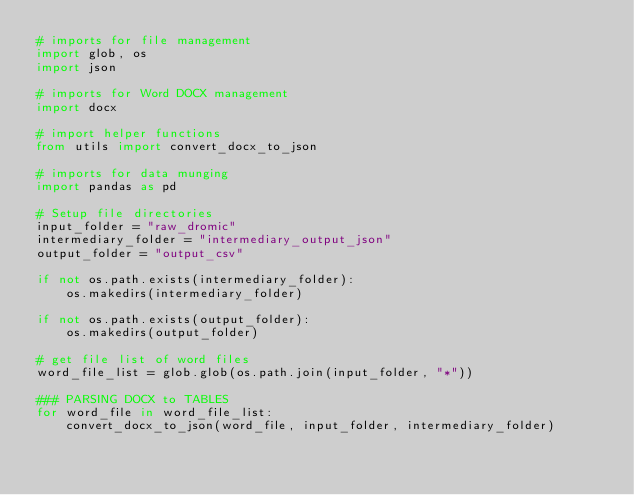Convert code to text. <code><loc_0><loc_0><loc_500><loc_500><_Python_># imports for file management
import glob, os
import json

# imports for Word DOCX management
import docx

# import helper functions
from utils import convert_docx_to_json

# imports for data munging
import pandas as pd

# Setup file directories
input_folder = "raw_dromic"
intermediary_folder = "intermediary_output_json"
output_folder = "output_csv"

if not os.path.exists(intermediary_folder):
    os.makedirs(intermediary_folder)

if not os.path.exists(output_folder):
    os.makedirs(output_folder)

# get file list of word files
word_file_list = glob.glob(os.path.join(input_folder, "*"))

### PARSING DOCX to TABLES
for word_file in word_file_list:
    convert_docx_to_json(word_file, input_folder, intermediary_folder)</code> 